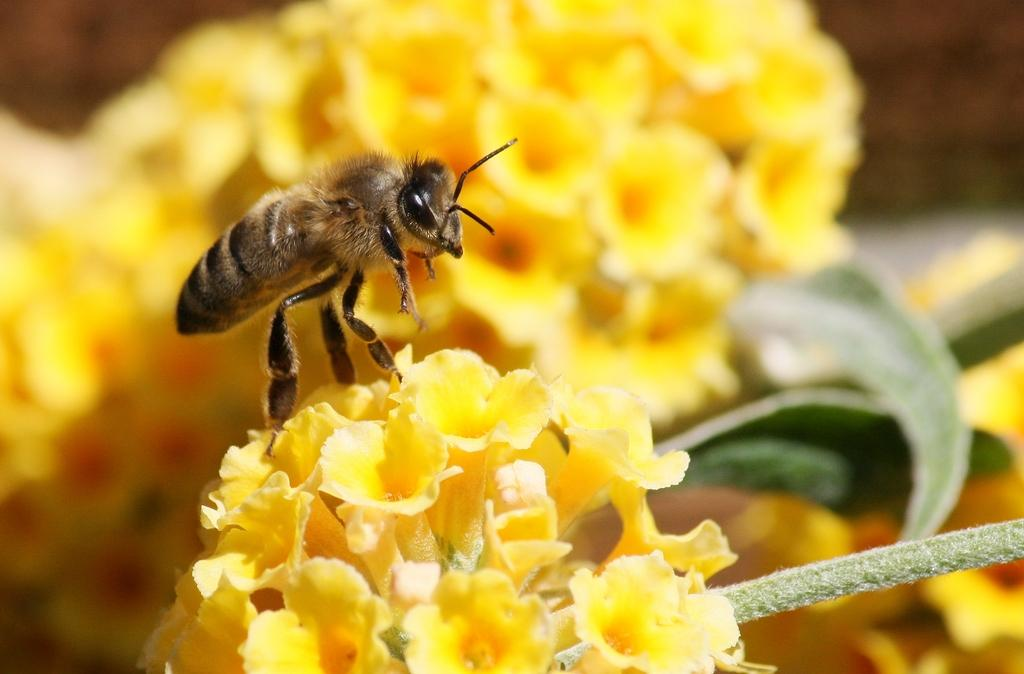What color is the flower in the image? The flower in the image is yellow. Is there anything on the flower in the image? Yes, there is a brown insect on the flower. What type of flesh can be seen on the giraffe in the image? There is no giraffe present in the image, and therefore no flesh can be seen. 